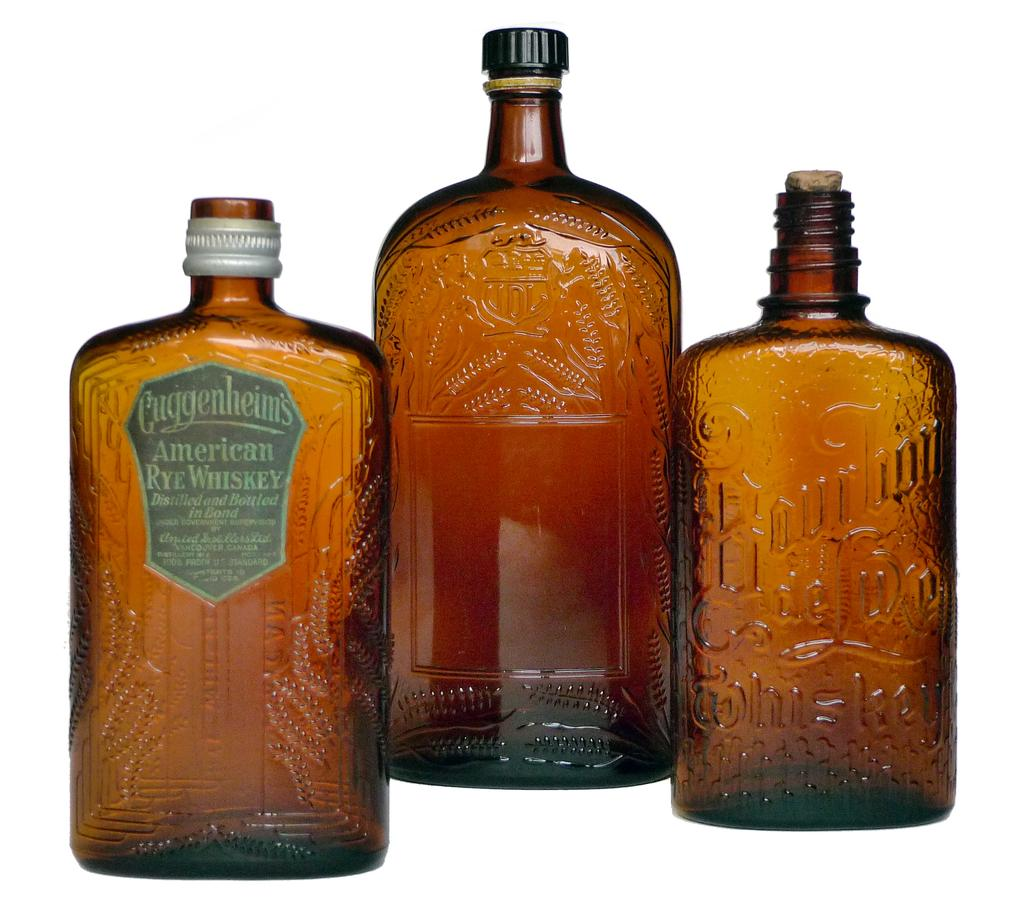<image>
Provide a brief description of the given image. three bottles next to one another with one of them labeled 'cuggenheims american rye whiskey' 